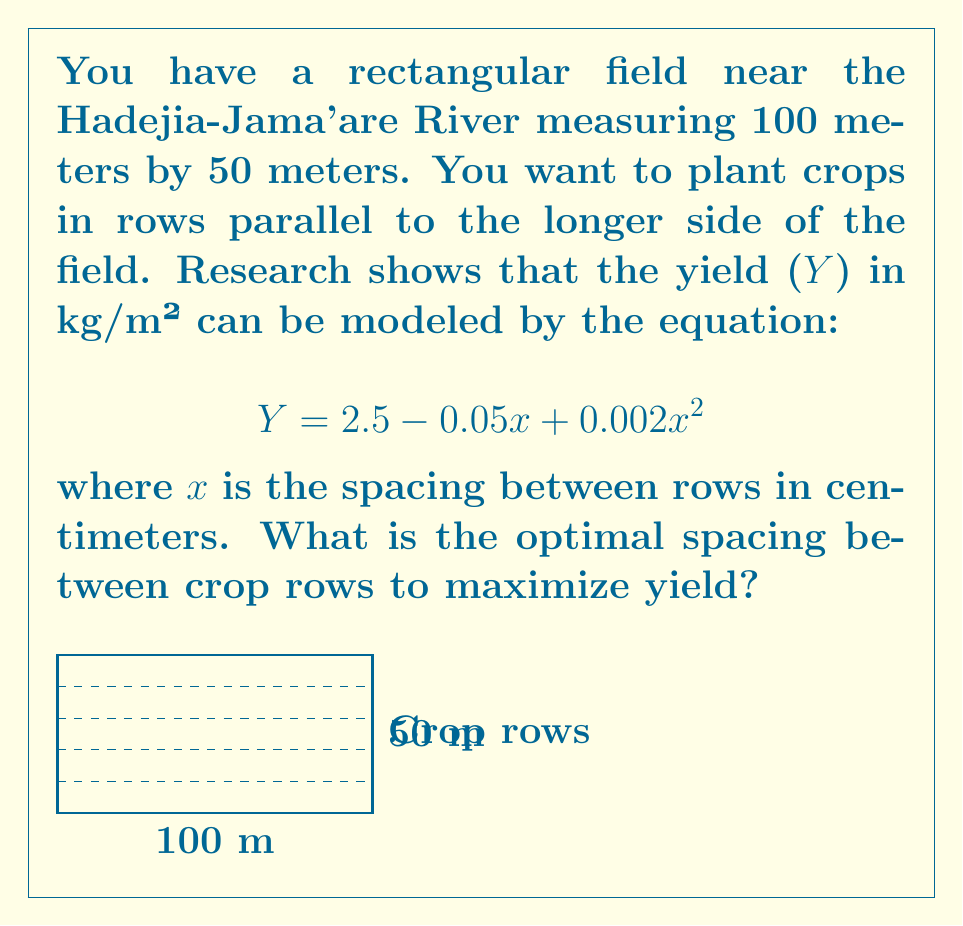Provide a solution to this math problem. To find the optimal spacing, we need to maximize the yield function Y. This can be done by finding the vertex of the parabola described by the equation.

Step 1: Identify the quadratic equation
$$Y = 2.5 - 0.05x + 0.002x^2$$

Step 2: Put the equation in standard form $(ax^2 + bx + c)$
$$Y = 0.002x^2 - 0.05x + 2.5$$

Step 3: Use the formula $x = -\frac{b}{2a}$ to find the x-coordinate of the vertex
$$x = -\frac{-0.05}{2(0.002)} = \frac{0.05}{0.004} = 12.5$$

Step 4: Convert the result to centimeters
The optimal spacing is 12.5 cm between crop rows.

Step 5: Verify by calculating the yield at this spacing
$$Y = 2.5 - 0.05(12.5) + 0.002(12.5)^2 = 2.5 - 0.625 + 0.3125 = 2.1875 \text{ kg/m²}$$

This is indeed the maximum yield achievable with this model.
Answer: 12.5 cm 